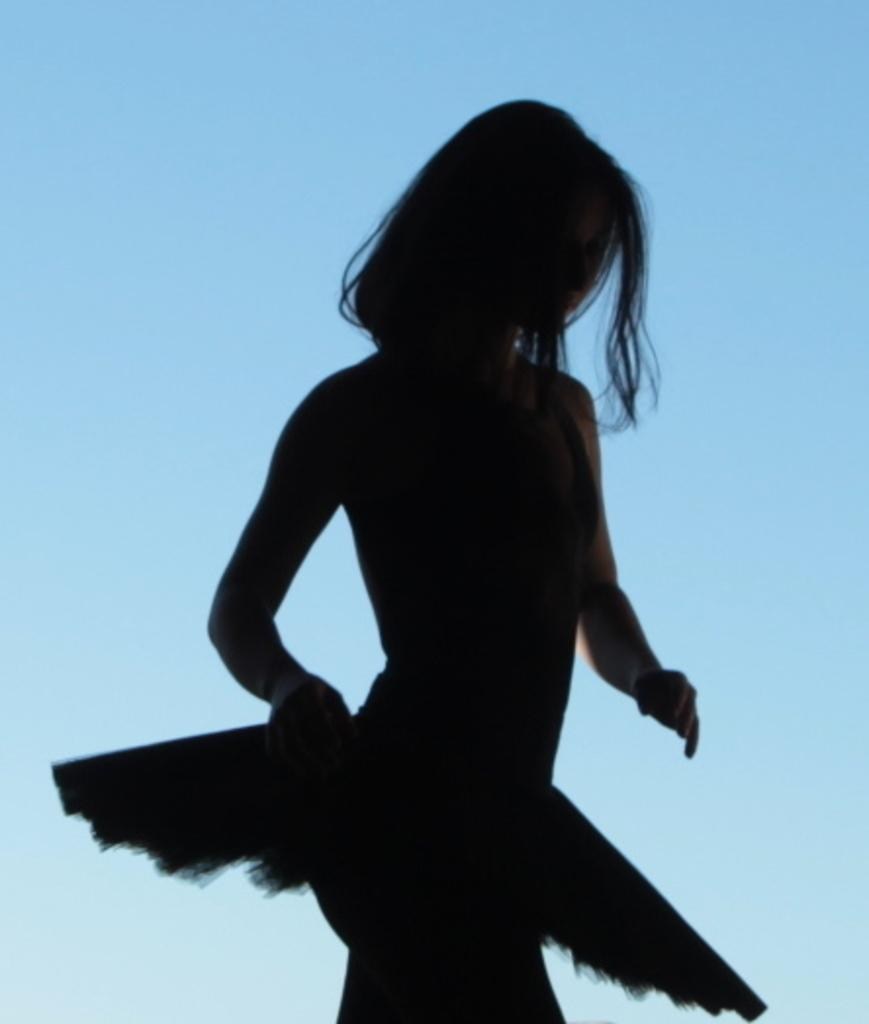Who is the main subject in the image? There is a lady in the center of the image. What type of bears can be seen performing on the stage in the image? There are no bears or stage present in the image; it features a lady in the center. 